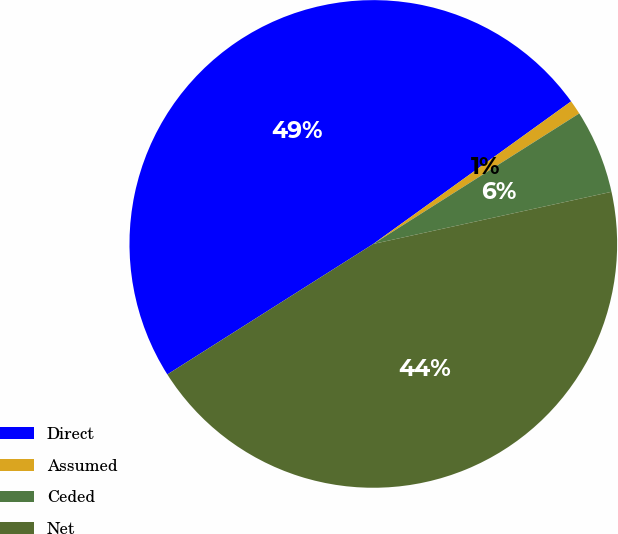Convert chart to OTSL. <chart><loc_0><loc_0><loc_500><loc_500><pie_chart><fcel>Direct<fcel>Assumed<fcel>Ceded<fcel>Net<nl><fcel>49.05%<fcel>0.95%<fcel>5.56%<fcel>44.44%<nl></chart> 